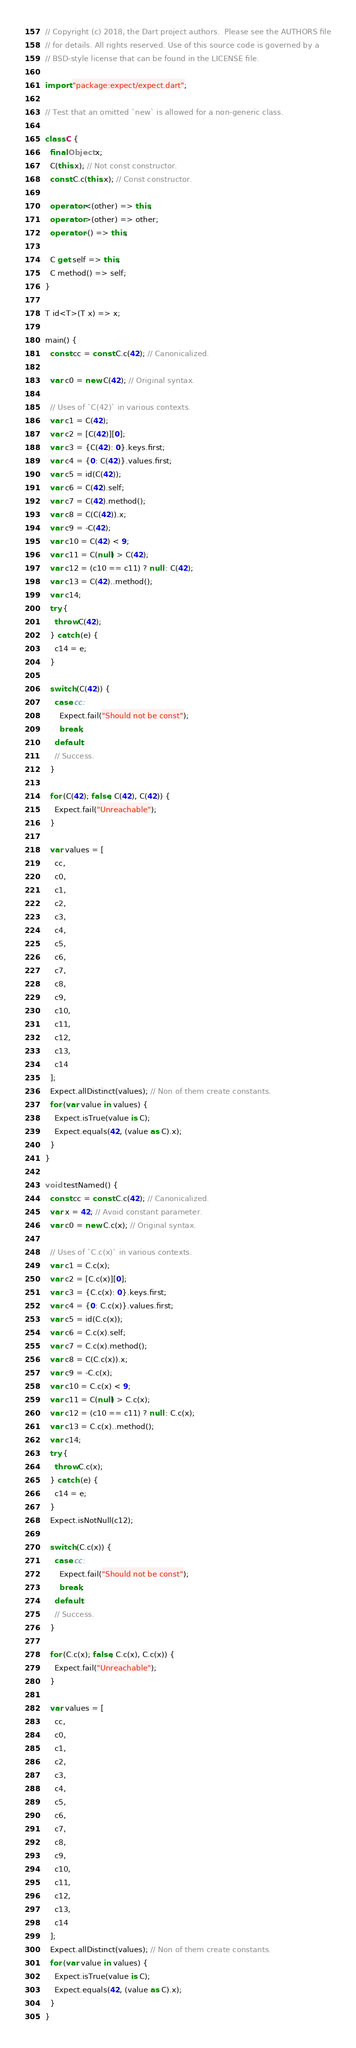Convert code to text. <code><loc_0><loc_0><loc_500><loc_500><_Dart_>// Copyright (c) 2018, the Dart project authors.  Please see the AUTHORS file
// for details. All rights reserved. Use of this source code is governed by a
// BSD-style license that can be found in the LICENSE file.

import "package:expect/expect.dart";

// Test that an omitted `new` is allowed for a non-generic class.

class C {
  final Object x;
  C(this.x); // Not const constructor.
  const C.c(this.x); // Const constructor.

  operator <(other) => this;
  operator >(other) => other;
  operator -() => this;

  C get self => this;
  C method() => self;
}

T id<T>(T x) => x;

main() {
  const cc = const C.c(42); // Canonicalized.

  var c0 = new C(42); // Original syntax.

  // Uses of `C(42)` in various contexts.
  var c1 = C(42);
  var c2 = [C(42)][0];
  var c3 = {C(42): 0}.keys.first;
  var c4 = {0: C(42)}.values.first;
  var c5 = id(C(42));
  var c6 = C(42).self;
  var c7 = C(42).method();
  var c8 = C(C(42)).x;
  var c9 = -C(42);
  var c10 = C(42) < 9;
  var c11 = C(null) > C(42);
  var c12 = (c10 == c11) ? null : C(42);
  var c13 = C(42)..method();
  var c14;
  try {
    throw C(42);
  } catch (e) {
    c14 = e;
  }

  switch (C(42)) {
    case cc:
      Expect.fail("Should not be const");
      break;
    default:
    // Success.
  }

  for (C(42); false; C(42), C(42)) {
    Expect.fail("Unreachable");
  }

  var values = [
    cc,
    c0,
    c1,
    c2,
    c3,
    c4,
    c5,
    c6,
    c7,
    c8,
    c9,
    c10,
    c11,
    c12,
    c13,
    c14
  ];
  Expect.allDistinct(values); // Non of them create constants.
  for (var value in values) {
    Expect.isTrue(value is C);
    Expect.equals(42, (value as C).x);
  }
}

void testNamed() {
  const cc = const C.c(42); // Canonicalized.
  var x = 42; // Avoid constant parameter.
  var c0 = new C.c(x); // Original syntax.

  // Uses of `C.c(x)` in various contexts.
  var c1 = C.c(x);
  var c2 = [C.c(x)][0];
  var c3 = {C.c(x): 0}.keys.first;
  var c4 = {0: C.c(x)}.values.first;
  var c5 = id(C.c(x));
  var c6 = C.c(x).self;
  var c7 = C.c(x).method();
  var c8 = C(C.c(x)).x;
  var c9 = -C.c(x);
  var c10 = C.c(x) < 9;
  var c11 = C(null) > C.c(x);
  var c12 = (c10 == c11) ? null : C.c(x);
  var c13 = C.c(x)..method();
  var c14;
  try {
    throw C.c(x);
  } catch (e) {
    c14 = e;
  }
  Expect.isNotNull(c12);

  switch (C.c(x)) {
    case cc:
      Expect.fail("Should not be const");
      break;
    default:
    // Success.
  }

  for (C.c(x); false; C.c(x), C.c(x)) {
    Expect.fail("Unreachable");
  }

  var values = [
    cc,
    c0,
    c1,
    c2,
    c3,
    c4,
    c5,
    c6,
    c7,
    c8,
    c9,
    c10,
    c11,
    c12,
    c13,
    c14
  ];
  Expect.allDistinct(values); // Non of them create constants.
  for (var value in values) {
    Expect.isTrue(value is C);
    Expect.equals(42, (value as C).x);
  }
}
</code> 